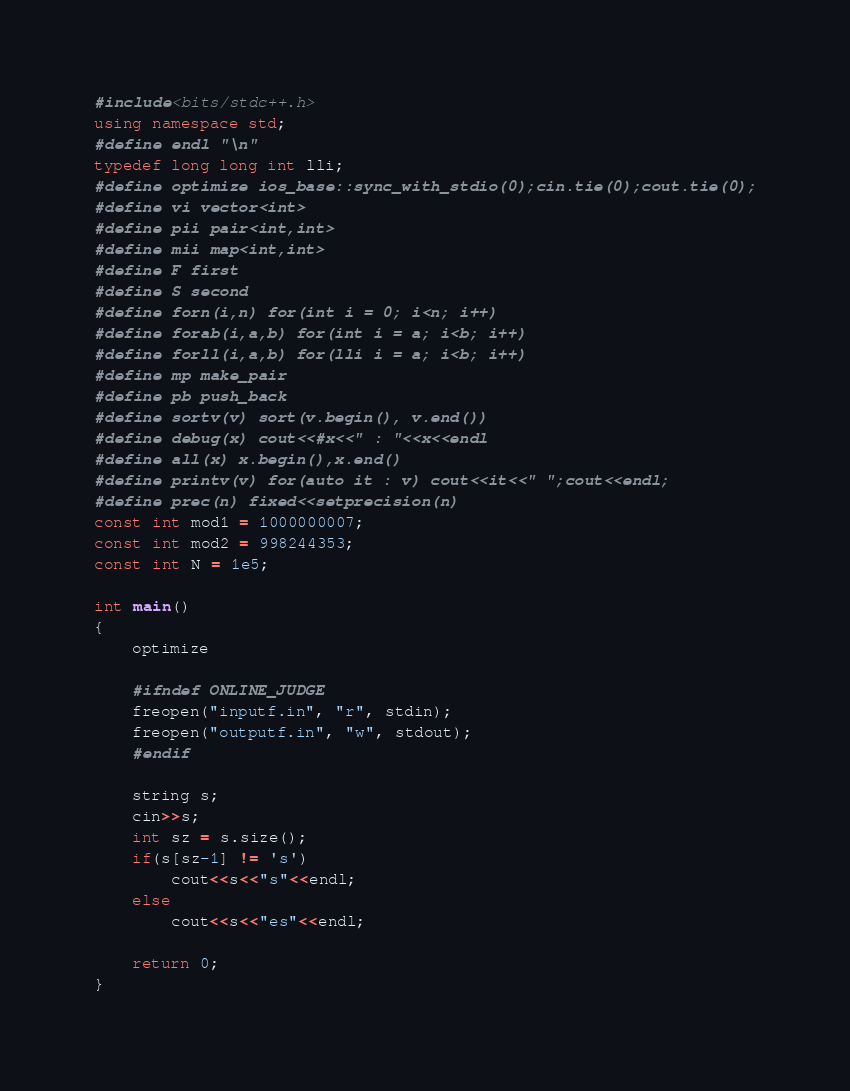<code> <loc_0><loc_0><loc_500><loc_500><_C++_>#include<bits/stdc++.h>
using namespace std;
#define endl "\n"
typedef long long int lli;
#define optimize ios_base::sync_with_stdio(0);cin.tie(0);cout.tie(0);
#define vi vector<int>
#define pii pair<int,int>
#define mii map<int,int>
#define F first
#define S second
#define forn(i,n) for(int i = 0; i<n; i++)
#define forab(i,a,b) for(int i = a; i<b; i++)
#define forll(i,a,b) for(lli i = a; i<b; i++)
#define mp make_pair
#define pb push_back
#define sortv(v) sort(v.begin(), v.end())
#define debug(x) cout<<#x<<" : "<<x<<endl
#define all(x) x.begin(),x.end()
#define printv(v) for(auto it : v) cout<<it<<" ";cout<<endl;
#define prec(n) fixed<<setprecision(n)
const int mod1 = 1000000007;
const int mod2 = 998244353;
const int N = 1e5;

int main()
{
	optimize

	#ifndef ONLINE_JUDGE
	freopen("inputf.in", "r", stdin);
	freopen("outputf.in", "w", stdout);
	#endif

	string s;
	cin>>s;
	int sz = s.size();
	if(s[sz-1] != 's')
		cout<<s<<"s"<<endl;
	else
		cout<<s<<"es"<<endl;

	return 0;
}</code> 